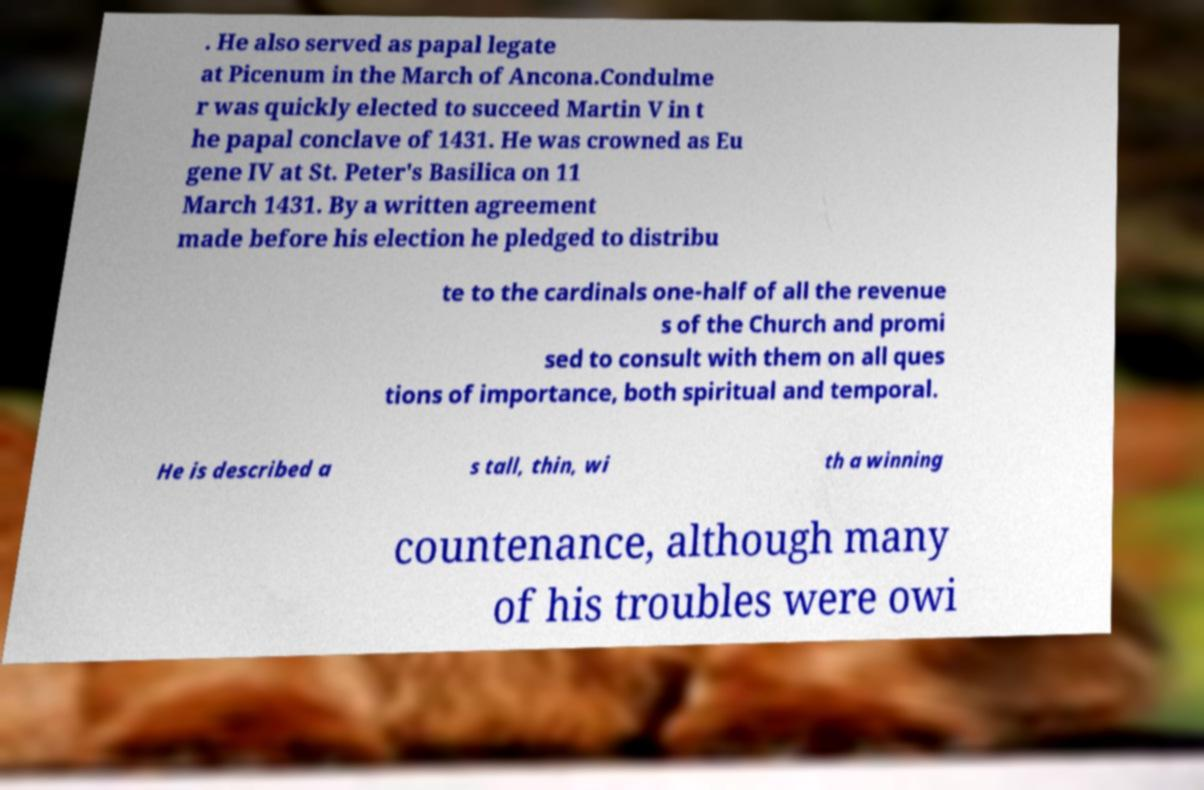Please read and relay the text visible in this image. What does it say? . He also served as papal legate at Picenum in the March of Ancona.Condulme r was quickly elected to succeed Martin V in t he papal conclave of 1431. He was crowned as Eu gene IV at St. Peter's Basilica on 11 March 1431. By a written agreement made before his election he pledged to distribu te to the cardinals one-half of all the revenue s of the Church and promi sed to consult with them on all ques tions of importance, both spiritual and temporal. He is described a s tall, thin, wi th a winning countenance, although many of his troubles were owi 